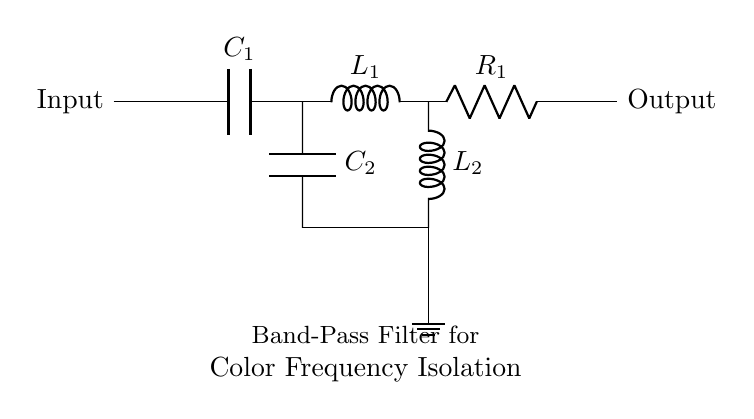What is the type of filter represented? The circuit diagram visually represents a band-pass filter, which is indicated by the specific arrangement of capacitors and inductors designed to allow a certain range of frequencies to pass while blocking others.
Answer: band-pass filter How many capacitors are in this circuit? There are two capacitors visible in the circuit diagram identified as C1 and C2, which are necessary components for the band-pass filter function.
Answer: two Which component is located at the input? The input of the circuit is connected directly to a short line, indicating the starting point for signal flow, leading to the capacitor C1.
Answer: capacitor C1 What happens to frequencies above the cutoff of this filter? Frequencies above the designated cutoff frequency will be attenuated or blocked by the filter due to the combination of the inductors and capacitors designed to isolate the desired frequency range.
Answer: attenuated What is the primary purpose of this filter? The primary purpose of a band-pass filter is to isolate specific frequencies from a broader range of signals, allowing only those within a specified range to be passed through to the output.
Answer: isolate specific frequencies What kind of components are used in the circuit? The circuit consists of two capacitors, two inductors, and one resistor, which collectively form the functionalities required for a band-pass filter in filtering color frequencies.
Answer: capacitors, inductors, resistor At what node do the two inductors connect to the ground? The inductors L1 and L2 connect to the ground at the same node where C2 is also connected, indicating a common return path for the unwanted frequency components.
Answer: at node L2 and C2 